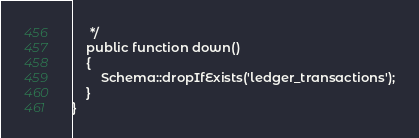Convert code to text. <code><loc_0><loc_0><loc_500><loc_500><_PHP_>     */
    public function down()
    {
        Schema::dropIfExists('ledger_transactions');
    }
}
</code> 